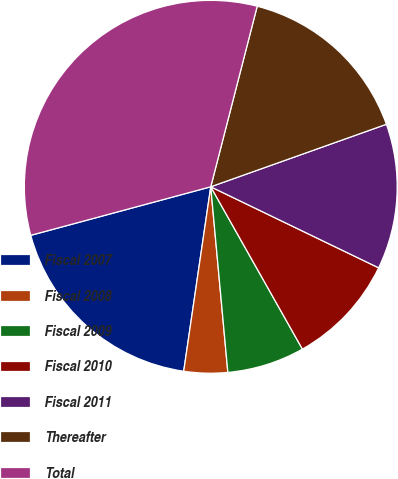<chart> <loc_0><loc_0><loc_500><loc_500><pie_chart><fcel>Fiscal 2007<fcel>Fiscal 2008<fcel>Fiscal 2009<fcel>Fiscal 2010<fcel>Fiscal 2011<fcel>Thereafter<fcel>Total<nl><fcel>18.49%<fcel>3.78%<fcel>6.72%<fcel>9.66%<fcel>12.6%<fcel>15.55%<fcel>33.2%<nl></chart> 